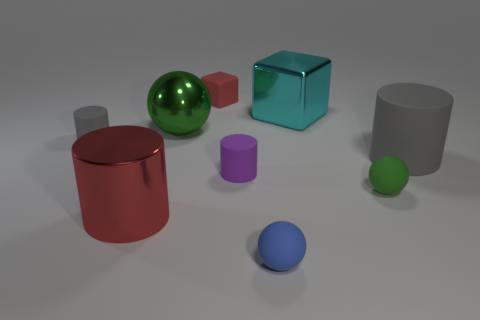Subtract all yellow cylinders. Subtract all cyan spheres. How many cylinders are left? 4 Add 1 large brown objects. How many objects exist? 10 Subtract all spheres. How many objects are left? 6 Add 5 small green spheres. How many small green spheres are left? 6 Add 7 blue rubber spheres. How many blue rubber spheres exist? 8 Subtract 0 cyan balls. How many objects are left? 9 Subtract all metal cylinders. Subtract all cyan shiny cubes. How many objects are left? 7 